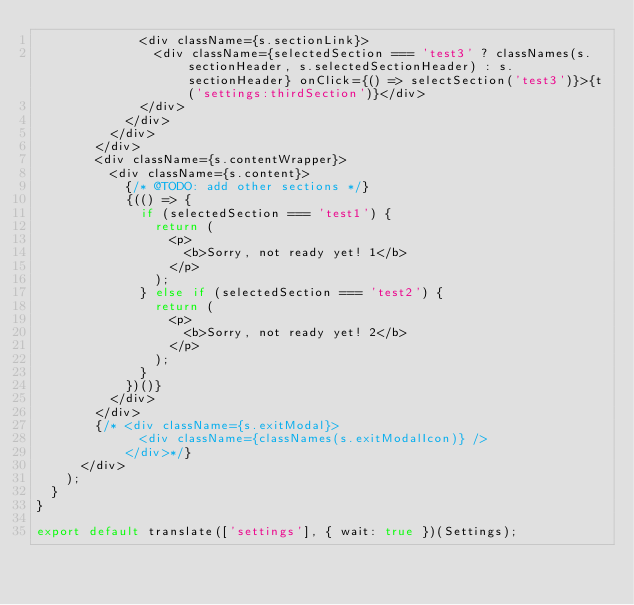Convert code to text. <code><loc_0><loc_0><loc_500><loc_500><_JavaScript_>              <div className={s.sectionLink}>
                <div className={selectedSection === 'test3' ? classNames(s.sectionHeader, s.selectedSectionHeader) : s.sectionHeader} onClick={() => selectSection('test3')}>{t('settings:thirdSection')}</div>
              </div>
            </div>
          </div>
        </div>
        <div className={s.contentWrapper}>
          <div className={s.content}>
            {/* @TODO: add other sections */}
            {(() => {
              if (selectedSection === 'test1') {
                return (
                  <p>
                    <b>Sorry, not ready yet! 1</b>
                  </p>
                );
              } else if (selectedSection === 'test2') {
                return (
                  <p>
                    <b>Sorry, not ready yet! 2</b>
                  </p>
                );
              }
            })()}
          </div>
        </div>
        {/* <div className={s.exitModal}>
              <div className={classNames(s.exitModalIcon)} />
            </div>*/}
      </div>
    );
  }
}

export default translate(['settings'], { wait: true })(Settings);
</code> 